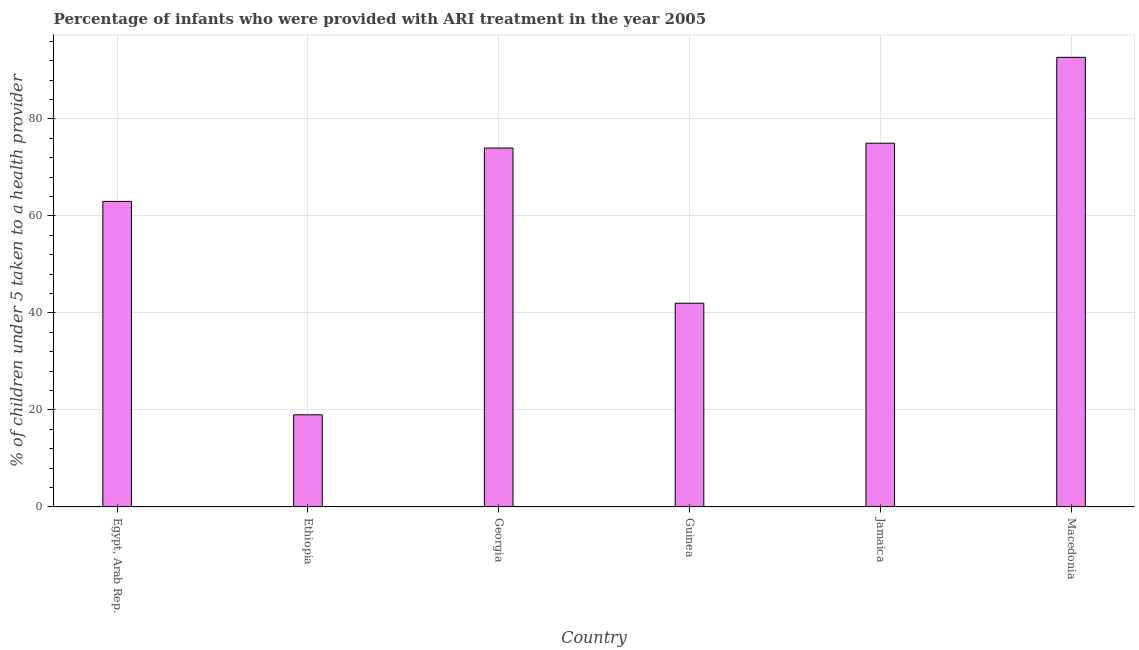What is the title of the graph?
Your answer should be very brief. Percentage of infants who were provided with ARI treatment in the year 2005. What is the label or title of the X-axis?
Your answer should be very brief. Country. What is the label or title of the Y-axis?
Provide a short and direct response. % of children under 5 taken to a health provider. What is the percentage of children who were provided with ari treatment in Guinea?
Keep it short and to the point. 42. Across all countries, what is the maximum percentage of children who were provided with ari treatment?
Your answer should be very brief. 92.7. In which country was the percentage of children who were provided with ari treatment maximum?
Ensure brevity in your answer.  Macedonia. In which country was the percentage of children who were provided with ari treatment minimum?
Keep it short and to the point. Ethiopia. What is the sum of the percentage of children who were provided with ari treatment?
Offer a very short reply. 365.7. What is the difference between the percentage of children who were provided with ari treatment in Guinea and Jamaica?
Offer a very short reply. -33. What is the average percentage of children who were provided with ari treatment per country?
Keep it short and to the point. 60.95. What is the median percentage of children who were provided with ari treatment?
Make the answer very short. 68.5. What is the ratio of the percentage of children who were provided with ari treatment in Georgia to that in Macedonia?
Your response must be concise. 0.8. What is the difference between the highest and the second highest percentage of children who were provided with ari treatment?
Give a very brief answer. 17.7. What is the difference between the highest and the lowest percentage of children who were provided with ari treatment?
Give a very brief answer. 73.7. In how many countries, is the percentage of children who were provided with ari treatment greater than the average percentage of children who were provided with ari treatment taken over all countries?
Your response must be concise. 4. How many bars are there?
Give a very brief answer. 6. How many countries are there in the graph?
Your answer should be compact. 6. What is the difference between two consecutive major ticks on the Y-axis?
Provide a short and direct response. 20. What is the % of children under 5 taken to a health provider of Egypt, Arab Rep.?
Offer a very short reply. 63. What is the % of children under 5 taken to a health provider in Ethiopia?
Provide a succinct answer. 19. What is the % of children under 5 taken to a health provider of Guinea?
Your answer should be compact. 42. What is the % of children under 5 taken to a health provider in Jamaica?
Your answer should be very brief. 75. What is the % of children under 5 taken to a health provider of Macedonia?
Your response must be concise. 92.7. What is the difference between the % of children under 5 taken to a health provider in Egypt, Arab Rep. and Jamaica?
Offer a very short reply. -12. What is the difference between the % of children under 5 taken to a health provider in Egypt, Arab Rep. and Macedonia?
Make the answer very short. -29.7. What is the difference between the % of children under 5 taken to a health provider in Ethiopia and Georgia?
Ensure brevity in your answer.  -55. What is the difference between the % of children under 5 taken to a health provider in Ethiopia and Guinea?
Make the answer very short. -23. What is the difference between the % of children under 5 taken to a health provider in Ethiopia and Jamaica?
Your answer should be compact. -56. What is the difference between the % of children under 5 taken to a health provider in Ethiopia and Macedonia?
Provide a succinct answer. -73.7. What is the difference between the % of children under 5 taken to a health provider in Georgia and Guinea?
Offer a terse response. 32. What is the difference between the % of children under 5 taken to a health provider in Georgia and Jamaica?
Keep it short and to the point. -1. What is the difference between the % of children under 5 taken to a health provider in Georgia and Macedonia?
Provide a succinct answer. -18.7. What is the difference between the % of children under 5 taken to a health provider in Guinea and Jamaica?
Ensure brevity in your answer.  -33. What is the difference between the % of children under 5 taken to a health provider in Guinea and Macedonia?
Provide a short and direct response. -50.7. What is the difference between the % of children under 5 taken to a health provider in Jamaica and Macedonia?
Your answer should be compact. -17.7. What is the ratio of the % of children under 5 taken to a health provider in Egypt, Arab Rep. to that in Ethiopia?
Your answer should be very brief. 3.32. What is the ratio of the % of children under 5 taken to a health provider in Egypt, Arab Rep. to that in Georgia?
Your answer should be compact. 0.85. What is the ratio of the % of children under 5 taken to a health provider in Egypt, Arab Rep. to that in Guinea?
Provide a succinct answer. 1.5. What is the ratio of the % of children under 5 taken to a health provider in Egypt, Arab Rep. to that in Jamaica?
Give a very brief answer. 0.84. What is the ratio of the % of children under 5 taken to a health provider in Egypt, Arab Rep. to that in Macedonia?
Offer a terse response. 0.68. What is the ratio of the % of children under 5 taken to a health provider in Ethiopia to that in Georgia?
Your answer should be very brief. 0.26. What is the ratio of the % of children under 5 taken to a health provider in Ethiopia to that in Guinea?
Offer a very short reply. 0.45. What is the ratio of the % of children under 5 taken to a health provider in Ethiopia to that in Jamaica?
Ensure brevity in your answer.  0.25. What is the ratio of the % of children under 5 taken to a health provider in Ethiopia to that in Macedonia?
Your answer should be compact. 0.2. What is the ratio of the % of children under 5 taken to a health provider in Georgia to that in Guinea?
Keep it short and to the point. 1.76. What is the ratio of the % of children under 5 taken to a health provider in Georgia to that in Jamaica?
Your answer should be compact. 0.99. What is the ratio of the % of children under 5 taken to a health provider in Georgia to that in Macedonia?
Offer a very short reply. 0.8. What is the ratio of the % of children under 5 taken to a health provider in Guinea to that in Jamaica?
Ensure brevity in your answer.  0.56. What is the ratio of the % of children under 5 taken to a health provider in Guinea to that in Macedonia?
Ensure brevity in your answer.  0.45. What is the ratio of the % of children under 5 taken to a health provider in Jamaica to that in Macedonia?
Provide a short and direct response. 0.81. 